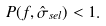<formula> <loc_0><loc_0><loc_500><loc_500>P ( f , \hat { \sigma } _ { s e l } ) < 1 .</formula> 